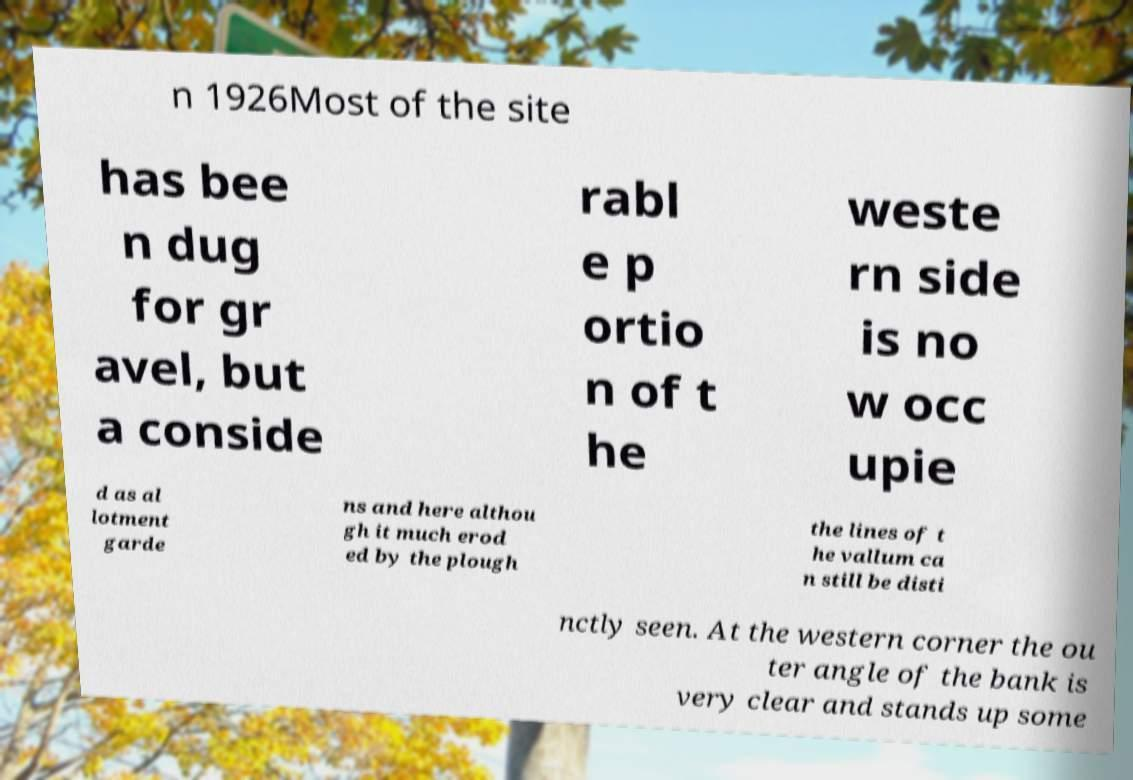Could you assist in decoding the text presented in this image and type it out clearly? n 1926Most of the site has bee n dug for gr avel, but a conside rabl e p ortio n of t he weste rn side is no w occ upie d as al lotment garde ns and here althou gh it much erod ed by the plough the lines of t he vallum ca n still be disti nctly seen. At the western corner the ou ter angle of the bank is very clear and stands up some 